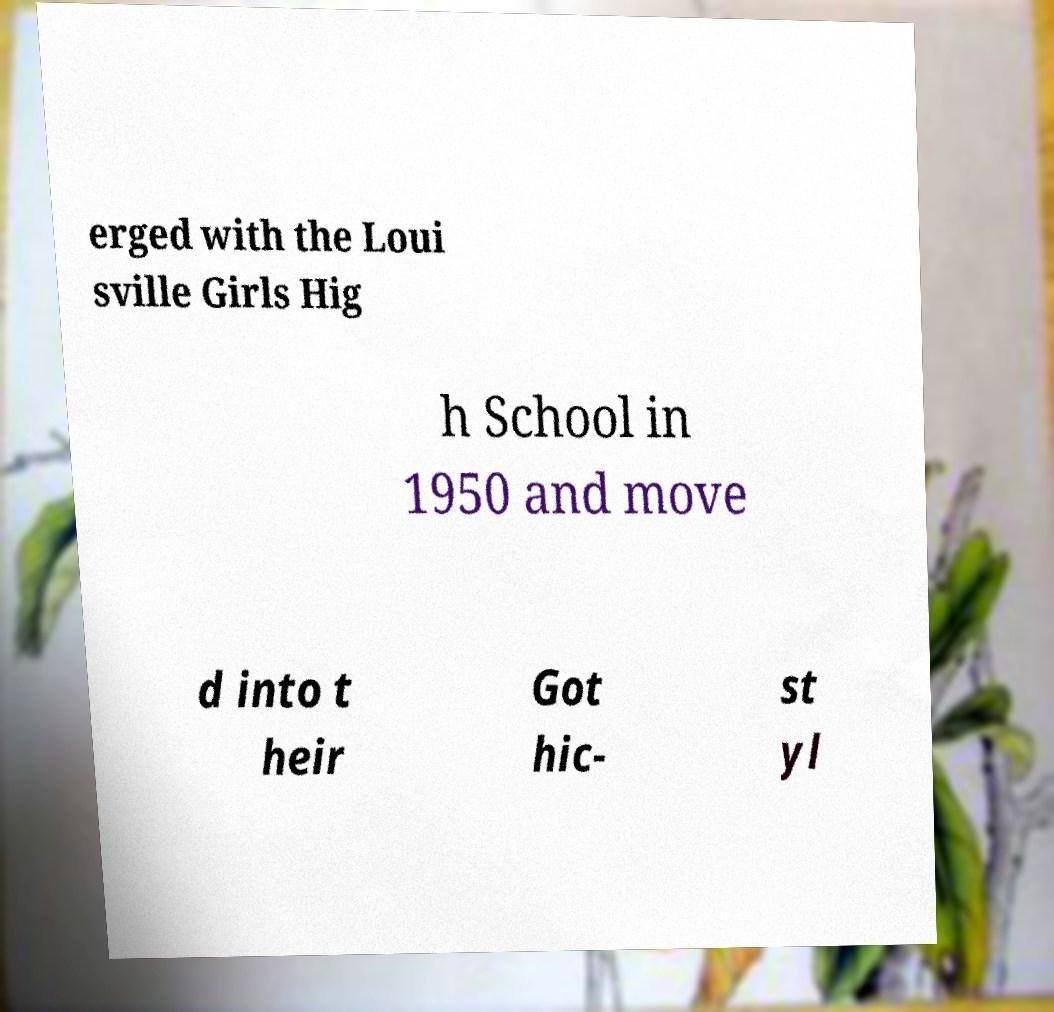Please read and relay the text visible in this image. What does it say? erged with the Loui sville Girls Hig h School in 1950 and move d into t heir Got hic- st yl 